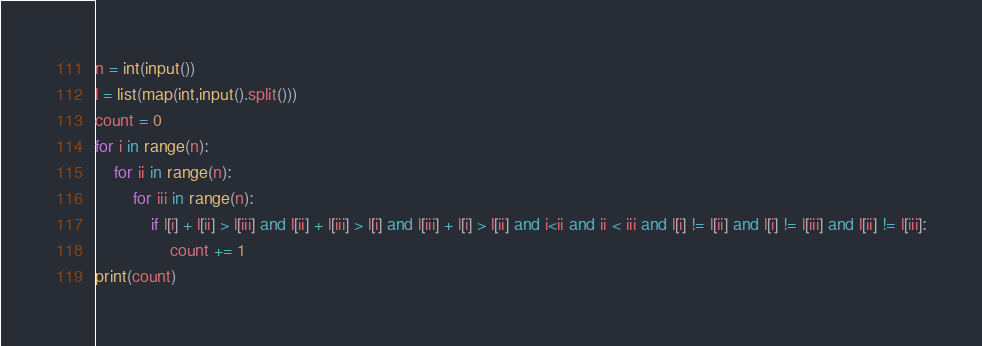<code> <loc_0><loc_0><loc_500><loc_500><_Python_>n = int(input())
l = list(map(int,input().split()))
count = 0
for i in range(n):
    for ii in range(n):
        for iii in range(n):
            if l[i] + l[ii] > l[iii] and l[ii] + l[iii] > l[i] and l[iii] + l[i] > l[ii] and i<ii and ii < iii and l[i] != l[ii] and l[i] != l[iii] and l[ii] != l[iii]:
                count += 1
print(count)</code> 